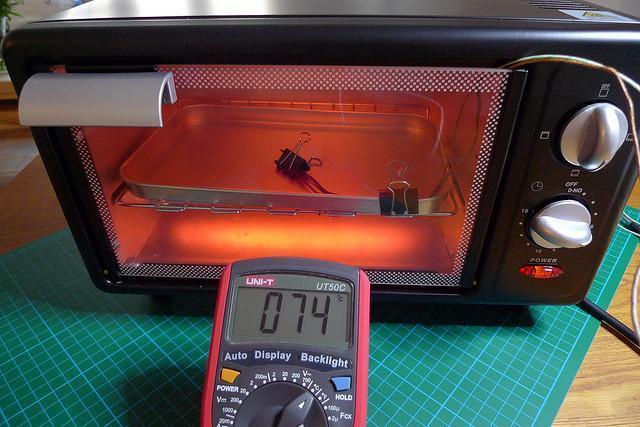How many ovens are visible?
Give a very brief answer. 1. How many pizza paddles are on top of the oven?
Give a very brief answer. 0. 